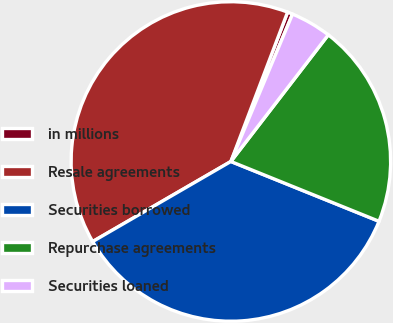<chart> <loc_0><loc_0><loc_500><loc_500><pie_chart><fcel>in millions<fcel>Resale agreements<fcel>Securities borrowed<fcel>Repurchase agreements<fcel>Securities loaned<nl><fcel>0.53%<fcel>39.13%<fcel>35.53%<fcel>20.67%<fcel>4.13%<nl></chart> 